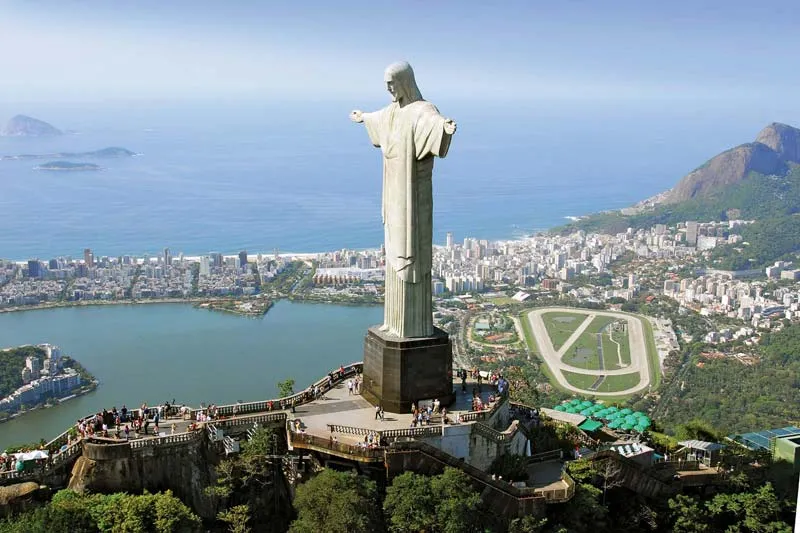What does this statue symbolize and why is it significant? The Christ the Redeemer statue is not only an iconic symbol of Rio de Janeiro but also represents the embracing nature and warmth of the Brazilian people. Positioned with outstretched arms, it symbolizes peace, welcoming all visitors. The statue is also a portrayal of the Christian faith held by many in Brazil, standing as a spiritual guardian overlooking the city. Its construction in 1931 was intended as a symbol of hope during challenging times. Today, it remains a powerful icon of human creativity and spiritual conviction, drawing millions of visitors each year. 